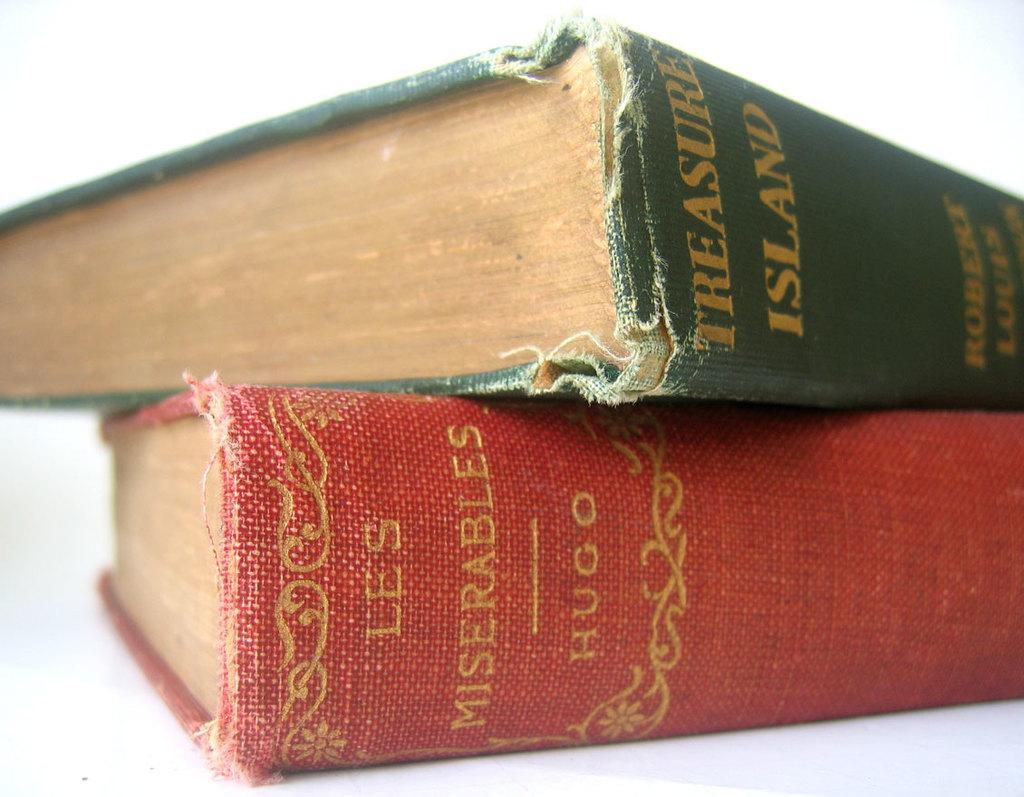<image>
Provide a brief description of the given image. Treasure Island and Les miserable novels stacked on top of each other. 